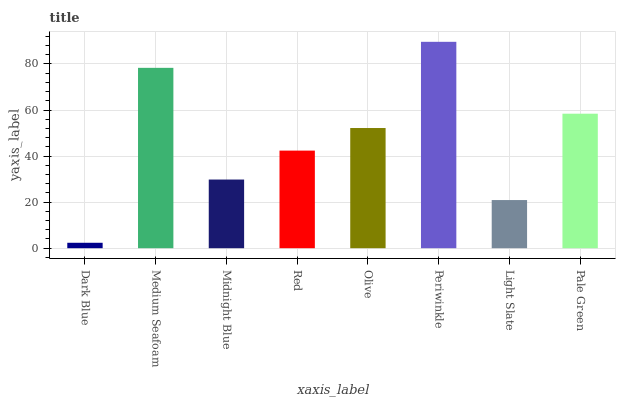Is Dark Blue the minimum?
Answer yes or no. Yes. Is Periwinkle the maximum?
Answer yes or no. Yes. Is Medium Seafoam the minimum?
Answer yes or no. No. Is Medium Seafoam the maximum?
Answer yes or no. No. Is Medium Seafoam greater than Dark Blue?
Answer yes or no. Yes. Is Dark Blue less than Medium Seafoam?
Answer yes or no. Yes. Is Dark Blue greater than Medium Seafoam?
Answer yes or no. No. Is Medium Seafoam less than Dark Blue?
Answer yes or no. No. Is Olive the high median?
Answer yes or no. Yes. Is Red the low median?
Answer yes or no. Yes. Is Dark Blue the high median?
Answer yes or no. No. Is Olive the low median?
Answer yes or no. No. 